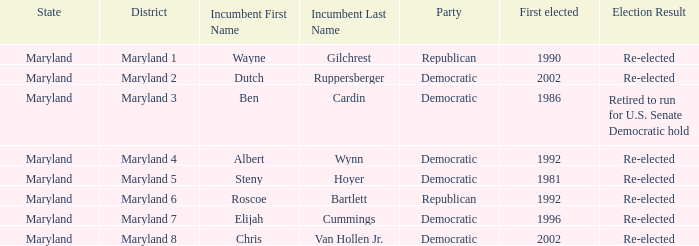Who is the incumbent who was first elected before 2002 from the maryland 3 district? Ben Cardin. 